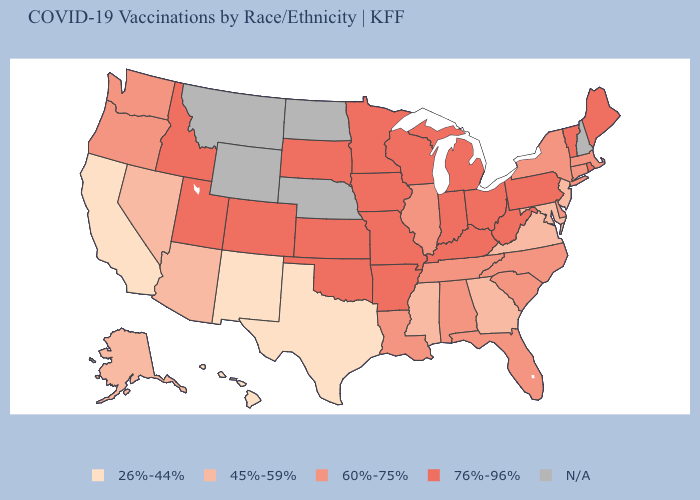What is the lowest value in states that border Delaware?
Give a very brief answer. 45%-59%. Among the states that border Kentucky , does West Virginia have the highest value?
Keep it brief. Yes. What is the value of Arizona?
Write a very short answer. 45%-59%. Name the states that have a value in the range 45%-59%?
Short answer required. Alaska, Arizona, Georgia, Maryland, Mississippi, Nevada, New Jersey, Virginia. What is the value of Iowa?
Keep it brief. 76%-96%. What is the value of Vermont?
Quick response, please. 76%-96%. Which states have the lowest value in the MidWest?
Quick response, please. Illinois. Among the states that border Delaware , which have the highest value?
Be succinct. Pennsylvania. Does the first symbol in the legend represent the smallest category?
Concise answer only. Yes. What is the lowest value in states that border New York?
Write a very short answer. 45%-59%. Name the states that have a value in the range 60%-75%?
Keep it brief. Alabama, Connecticut, Delaware, Florida, Illinois, Louisiana, Massachusetts, New York, North Carolina, Oregon, South Carolina, Tennessee, Washington. Does the first symbol in the legend represent the smallest category?
Quick response, please. Yes. Name the states that have a value in the range 76%-96%?
Keep it brief. Arkansas, Colorado, Idaho, Indiana, Iowa, Kansas, Kentucky, Maine, Michigan, Minnesota, Missouri, Ohio, Oklahoma, Pennsylvania, Rhode Island, South Dakota, Utah, Vermont, West Virginia, Wisconsin. What is the value of Mississippi?
Quick response, please. 45%-59%. What is the lowest value in the West?
Be succinct. 26%-44%. 